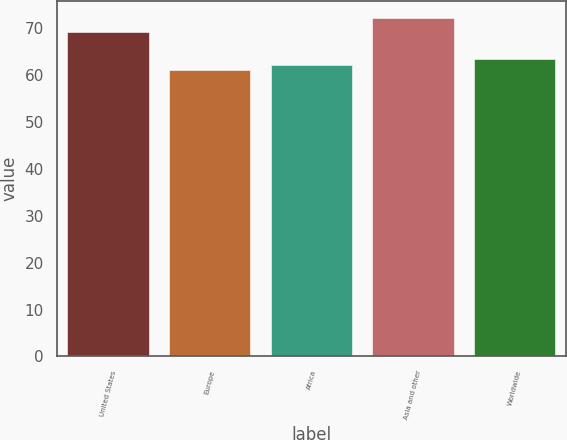<chart> <loc_0><loc_0><loc_500><loc_500><bar_chart><fcel>United States<fcel>Europe<fcel>Africa<fcel>Asia and other<fcel>Worldwide<nl><fcel>69.23<fcel>60.99<fcel>62.11<fcel>72.17<fcel>63.44<nl></chart> 